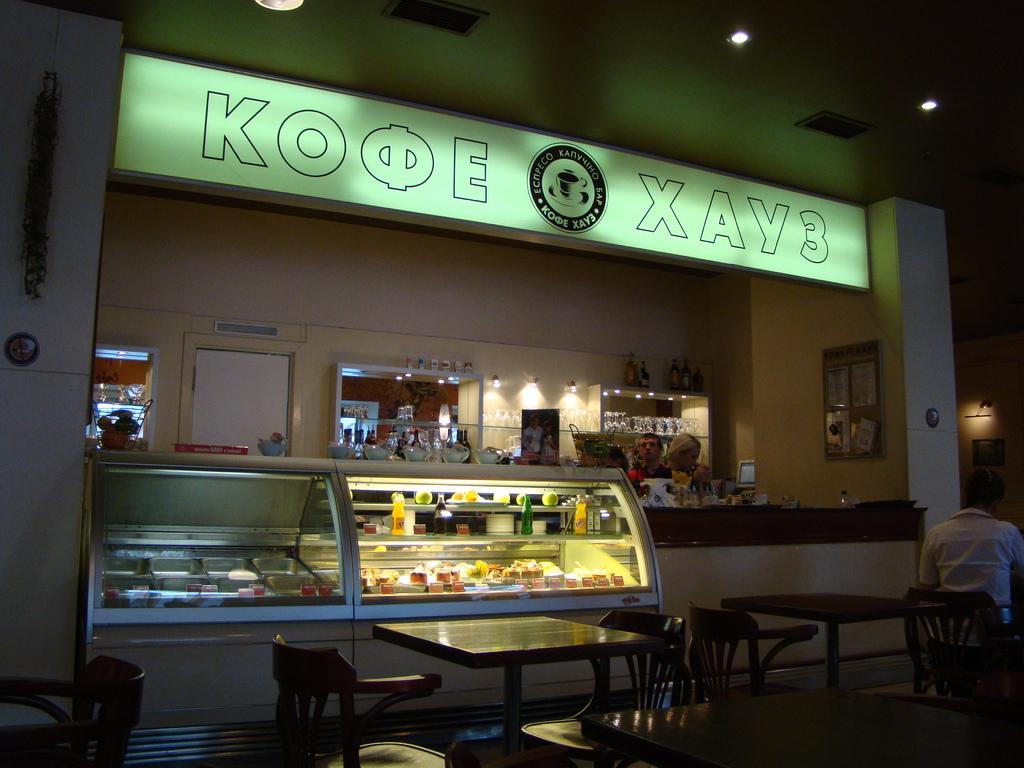How would you summarize this image in a sentence or two? In the image we can see there are people who are standing and there is a bakery in which the food items like pasties, juice bottles are stored in a fridge and there are tables and chairs, a person is sitting on the chair. 